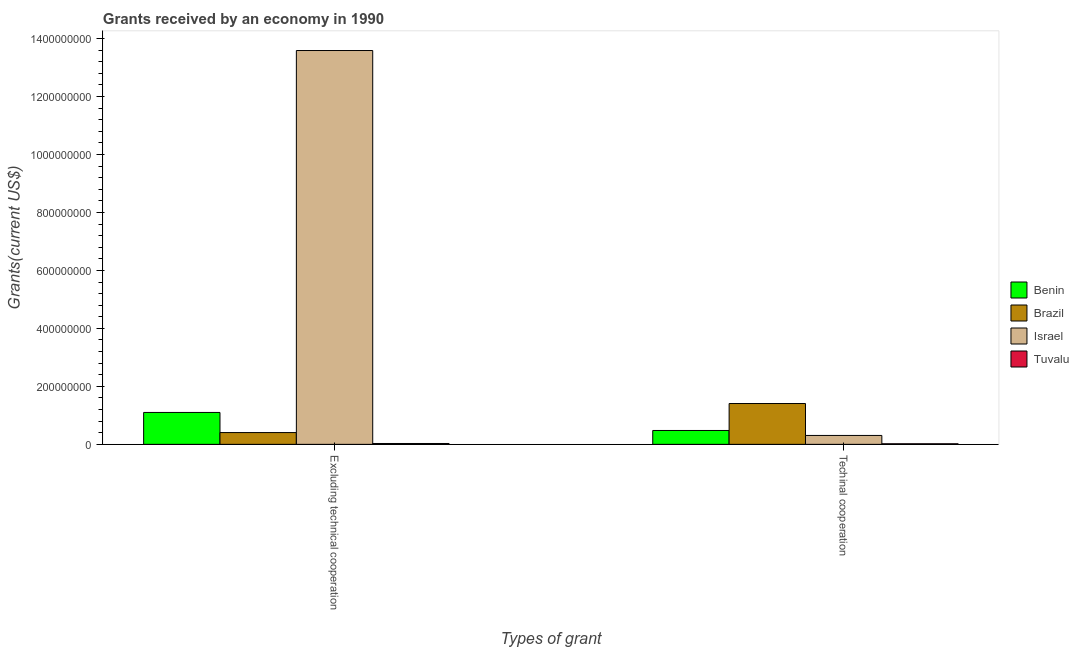How many groups of bars are there?
Make the answer very short. 2. How many bars are there on the 2nd tick from the left?
Keep it short and to the point. 4. What is the label of the 1st group of bars from the left?
Offer a terse response. Excluding technical cooperation. What is the amount of grants received(excluding technical cooperation) in Tuvalu?
Offer a terse response. 3.01e+06. Across all countries, what is the maximum amount of grants received(including technical cooperation)?
Make the answer very short. 1.41e+08. Across all countries, what is the minimum amount of grants received(including technical cooperation)?
Provide a succinct answer. 2.05e+06. In which country was the amount of grants received(excluding technical cooperation) minimum?
Your response must be concise. Tuvalu. What is the total amount of grants received(including technical cooperation) in the graph?
Keep it short and to the point. 2.22e+08. What is the difference between the amount of grants received(excluding technical cooperation) in Brazil and that in Benin?
Provide a succinct answer. -6.94e+07. What is the difference between the amount of grants received(excluding technical cooperation) in Brazil and the amount of grants received(including technical cooperation) in Benin?
Your answer should be compact. -7.22e+06. What is the average amount of grants received(excluding technical cooperation) per country?
Give a very brief answer. 3.78e+08. What is the difference between the amount of grants received(including technical cooperation) and amount of grants received(excluding technical cooperation) in Brazil?
Offer a terse response. 1.00e+08. In how many countries, is the amount of grants received(excluding technical cooperation) greater than 760000000 US$?
Your response must be concise. 1. What is the ratio of the amount of grants received(excluding technical cooperation) in Benin to that in Tuvalu?
Make the answer very short. 36.56. Is the amount of grants received(excluding technical cooperation) in Israel less than that in Benin?
Make the answer very short. No. What does the 4th bar from the left in Excluding technical cooperation represents?
Your response must be concise. Tuvalu. What does the 2nd bar from the right in Excluding technical cooperation represents?
Provide a short and direct response. Israel. How many bars are there?
Offer a very short reply. 8. How many countries are there in the graph?
Offer a terse response. 4. Does the graph contain grids?
Your answer should be very brief. No. How many legend labels are there?
Provide a succinct answer. 4. How are the legend labels stacked?
Keep it short and to the point. Vertical. What is the title of the graph?
Your answer should be very brief. Grants received by an economy in 1990. Does "Suriname" appear as one of the legend labels in the graph?
Provide a succinct answer. No. What is the label or title of the X-axis?
Your response must be concise. Types of grant. What is the label or title of the Y-axis?
Your answer should be compact. Grants(current US$). What is the Grants(current US$) in Benin in Excluding technical cooperation?
Provide a succinct answer. 1.10e+08. What is the Grants(current US$) in Brazil in Excluding technical cooperation?
Ensure brevity in your answer.  4.07e+07. What is the Grants(current US$) in Israel in Excluding technical cooperation?
Your answer should be very brief. 1.36e+09. What is the Grants(current US$) in Tuvalu in Excluding technical cooperation?
Offer a very short reply. 3.01e+06. What is the Grants(current US$) in Benin in Techinal cooperation?
Your answer should be very brief. 4.79e+07. What is the Grants(current US$) in Brazil in Techinal cooperation?
Offer a terse response. 1.41e+08. What is the Grants(current US$) of Israel in Techinal cooperation?
Your answer should be very brief. 3.07e+07. What is the Grants(current US$) in Tuvalu in Techinal cooperation?
Ensure brevity in your answer.  2.05e+06. Across all Types of grant, what is the maximum Grants(current US$) in Benin?
Keep it short and to the point. 1.10e+08. Across all Types of grant, what is the maximum Grants(current US$) in Brazil?
Keep it short and to the point. 1.41e+08. Across all Types of grant, what is the maximum Grants(current US$) of Israel?
Provide a succinct answer. 1.36e+09. Across all Types of grant, what is the maximum Grants(current US$) in Tuvalu?
Make the answer very short. 3.01e+06. Across all Types of grant, what is the minimum Grants(current US$) in Benin?
Ensure brevity in your answer.  4.79e+07. Across all Types of grant, what is the minimum Grants(current US$) in Brazil?
Make the answer very short. 4.07e+07. Across all Types of grant, what is the minimum Grants(current US$) in Israel?
Make the answer very short. 3.07e+07. Across all Types of grant, what is the minimum Grants(current US$) of Tuvalu?
Give a very brief answer. 2.05e+06. What is the total Grants(current US$) in Benin in the graph?
Keep it short and to the point. 1.58e+08. What is the total Grants(current US$) in Brazil in the graph?
Keep it short and to the point. 1.82e+08. What is the total Grants(current US$) of Israel in the graph?
Offer a very short reply. 1.39e+09. What is the total Grants(current US$) in Tuvalu in the graph?
Offer a very short reply. 5.06e+06. What is the difference between the Grants(current US$) of Benin in Excluding technical cooperation and that in Techinal cooperation?
Ensure brevity in your answer.  6.22e+07. What is the difference between the Grants(current US$) in Brazil in Excluding technical cooperation and that in Techinal cooperation?
Make the answer very short. -1.00e+08. What is the difference between the Grants(current US$) in Israel in Excluding technical cooperation and that in Techinal cooperation?
Keep it short and to the point. 1.33e+09. What is the difference between the Grants(current US$) of Tuvalu in Excluding technical cooperation and that in Techinal cooperation?
Keep it short and to the point. 9.60e+05. What is the difference between the Grants(current US$) of Benin in Excluding technical cooperation and the Grants(current US$) of Brazil in Techinal cooperation?
Your response must be concise. -3.08e+07. What is the difference between the Grants(current US$) in Benin in Excluding technical cooperation and the Grants(current US$) in Israel in Techinal cooperation?
Your answer should be compact. 7.93e+07. What is the difference between the Grants(current US$) in Benin in Excluding technical cooperation and the Grants(current US$) in Tuvalu in Techinal cooperation?
Your response must be concise. 1.08e+08. What is the difference between the Grants(current US$) in Brazil in Excluding technical cooperation and the Grants(current US$) in Israel in Techinal cooperation?
Ensure brevity in your answer.  9.93e+06. What is the difference between the Grants(current US$) in Brazil in Excluding technical cooperation and the Grants(current US$) in Tuvalu in Techinal cooperation?
Your answer should be compact. 3.86e+07. What is the difference between the Grants(current US$) in Israel in Excluding technical cooperation and the Grants(current US$) in Tuvalu in Techinal cooperation?
Make the answer very short. 1.36e+09. What is the average Grants(current US$) in Benin per Types of grant?
Give a very brief answer. 7.90e+07. What is the average Grants(current US$) in Brazil per Types of grant?
Offer a terse response. 9.08e+07. What is the average Grants(current US$) in Israel per Types of grant?
Your answer should be compact. 6.95e+08. What is the average Grants(current US$) of Tuvalu per Types of grant?
Your answer should be compact. 2.53e+06. What is the difference between the Grants(current US$) in Benin and Grants(current US$) in Brazil in Excluding technical cooperation?
Ensure brevity in your answer.  6.94e+07. What is the difference between the Grants(current US$) in Benin and Grants(current US$) in Israel in Excluding technical cooperation?
Offer a terse response. -1.25e+09. What is the difference between the Grants(current US$) of Benin and Grants(current US$) of Tuvalu in Excluding technical cooperation?
Ensure brevity in your answer.  1.07e+08. What is the difference between the Grants(current US$) of Brazil and Grants(current US$) of Israel in Excluding technical cooperation?
Ensure brevity in your answer.  -1.32e+09. What is the difference between the Grants(current US$) of Brazil and Grants(current US$) of Tuvalu in Excluding technical cooperation?
Provide a succinct answer. 3.76e+07. What is the difference between the Grants(current US$) in Israel and Grants(current US$) in Tuvalu in Excluding technical cooperation?
Ensure brevity in your answer.  1.36e+09. What is the difference between the Grants(current US$) of Benin and Grants(current US$) of Brazil in Techinal cooperation?
Your answer should be very brief. -9.30e+07. What is the difference between the Grants(current US$) in Benin and Grants(current US$) in Israel in Techinal cooperation?
Your response must be concise. 1.72e+07. What is the difference between the Grants(current US$) of Benin and Grants(current US$) of Tuvalu in Techinal cooperation?
Make the answer very short. 4.58e+07. What is the difference between the Grants(current US$) in Brazil and Grants(current US$) in Israel in Techinal cooperation?
Offer a very short reply. 1.10e+08. What is the difference between the Grants(current US$) in Brazil and Grants(current US$) in Tuvalu in Techinal cooperation?
Give a very brief answer. 1.39e+08. What is the difference between the Grants(current US$) in Israel and Grants(current US$) in Tuvalu in Techinal cooperation?
Make the answer very short. 2.87e+07. What is the ratio of the Grants(current US$) in Benin in Excluding technical cooperation to that in Techinal cooperation?
Your answer should be compact. 2.3. What is the ratio of the Grants(current US$) of Brazil in Excluding technical cooperation to that in Techinal cooperation?
Give a very brief answer. 0.29. What is the ratio of the Grants(current US$) in Israel in Excluding technical cooperation to that in Techinal cooperation?
Offer a very short reply. 44.21. What is the ratio of the Grants(current US$) of Tuvalu in Excluding technical cooperation to that in Techinal cooperation?
Make the answer very short. 1.47. What is the difference between the highest and the second highest Grants(current US$) of Benin?
Keep it short and to the point. 6.22e+07. What is the difference between the highest and the second highest Grants(current US$) in Brazil?
Your answer should be compact. 1.00e+08. What is the difference between the highest and the second highest Grants(current US$) of Israel?
Give a very brief answer. 1.33e+09. What is the difference between the highest and the second highest Grants(current US$) in Tuvalu?
Provide a succinct answer. 9.60e+05. What is the difference between the highest and the lowest Grants(current US$) in Benin?
Your answer should be compact. 6.22e+07. What is the difference between the highest and the lowest Grants(current US$) of Brazil?
Provide a succinct answer. 1.00e+08. What is the difference between the highest and the lowest Grants(current US$) in Israel?
Give a very brief answer. 1.33e+09. What is the difference between the highest and the lowest Grants(current US$) of Tuvalu?
Make the answer very short. 9.60e+05. 